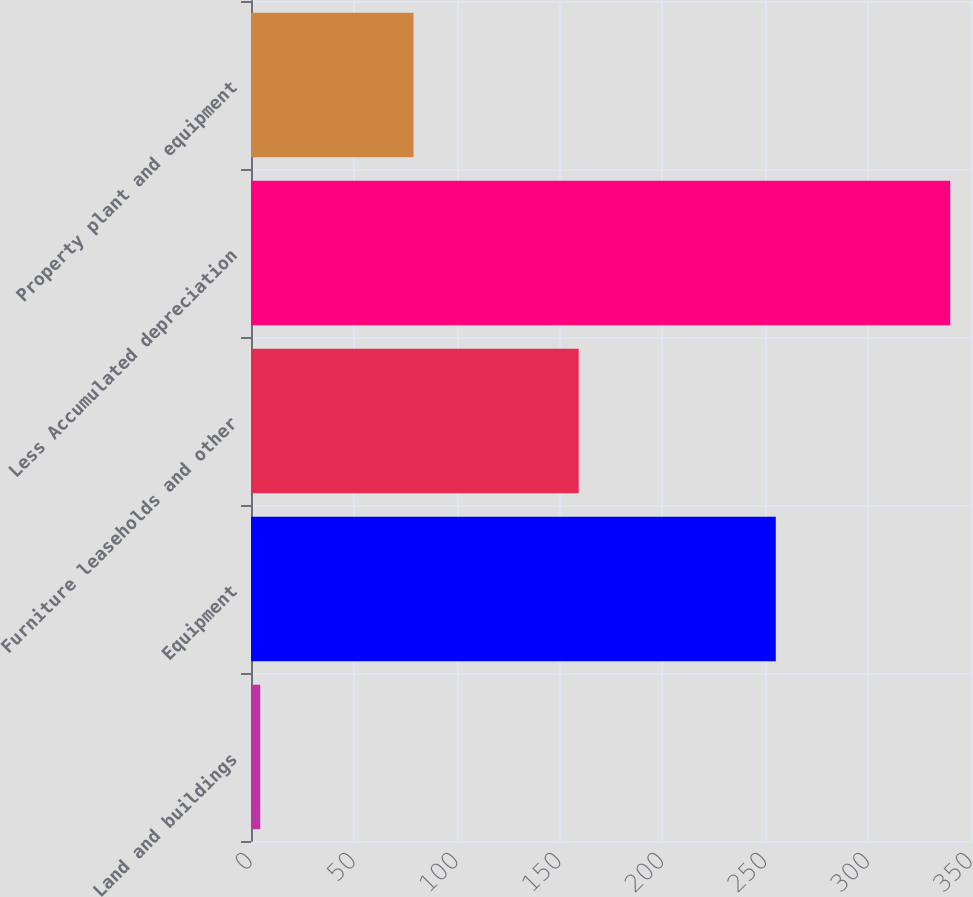Convert chart to OTSL. <chart><loc_0><loc_0><loc_500><loc_500><bar_chart><fcel>Land and buildings<fcel>Equipment<fcel>Furniture leaseholds and other<fcel>Less Accumulated depreciation<fcel>Property plant and equipment<nl><fcel>4.5<fcel>255.1<fcel>159.3<fcel>339.9<fcel>79<nl></chart> 